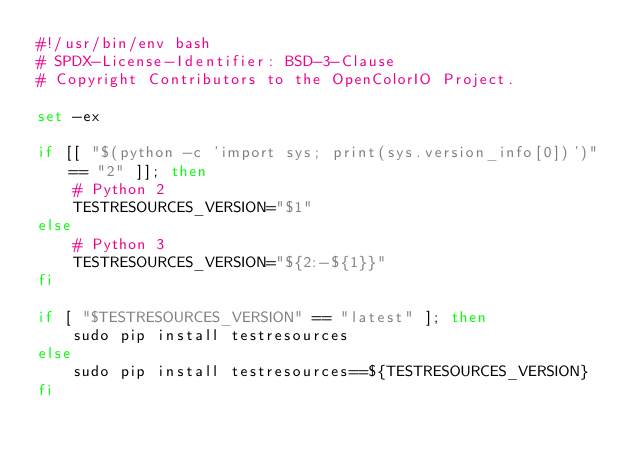<code> <loc_0><loc_0><loc_500><loc_500><_Bash_>#!/usr/bin/env bash
# SPDX-License-Identifier: BSD-3-Clause
# Copyright Contributors to the OpenColorIO Project.

set -ex

if [[ "$(python -c 'import sys; print(sys.version_info[0])')" == "2" ]]; then
    # Python 2
    TESTRESOURCES_VERSION="$1"
else
    # Python 3
    TESTRESOURCES_VERSION="${2:-${1}}"
fi

if [ "$TESTRESOURCES_VERSION" == "latest" ]; then
    sudo pip install testresources
else
    sudo pip install testresources==${TESTRESOURCES_VERSION}
fi
</code> 